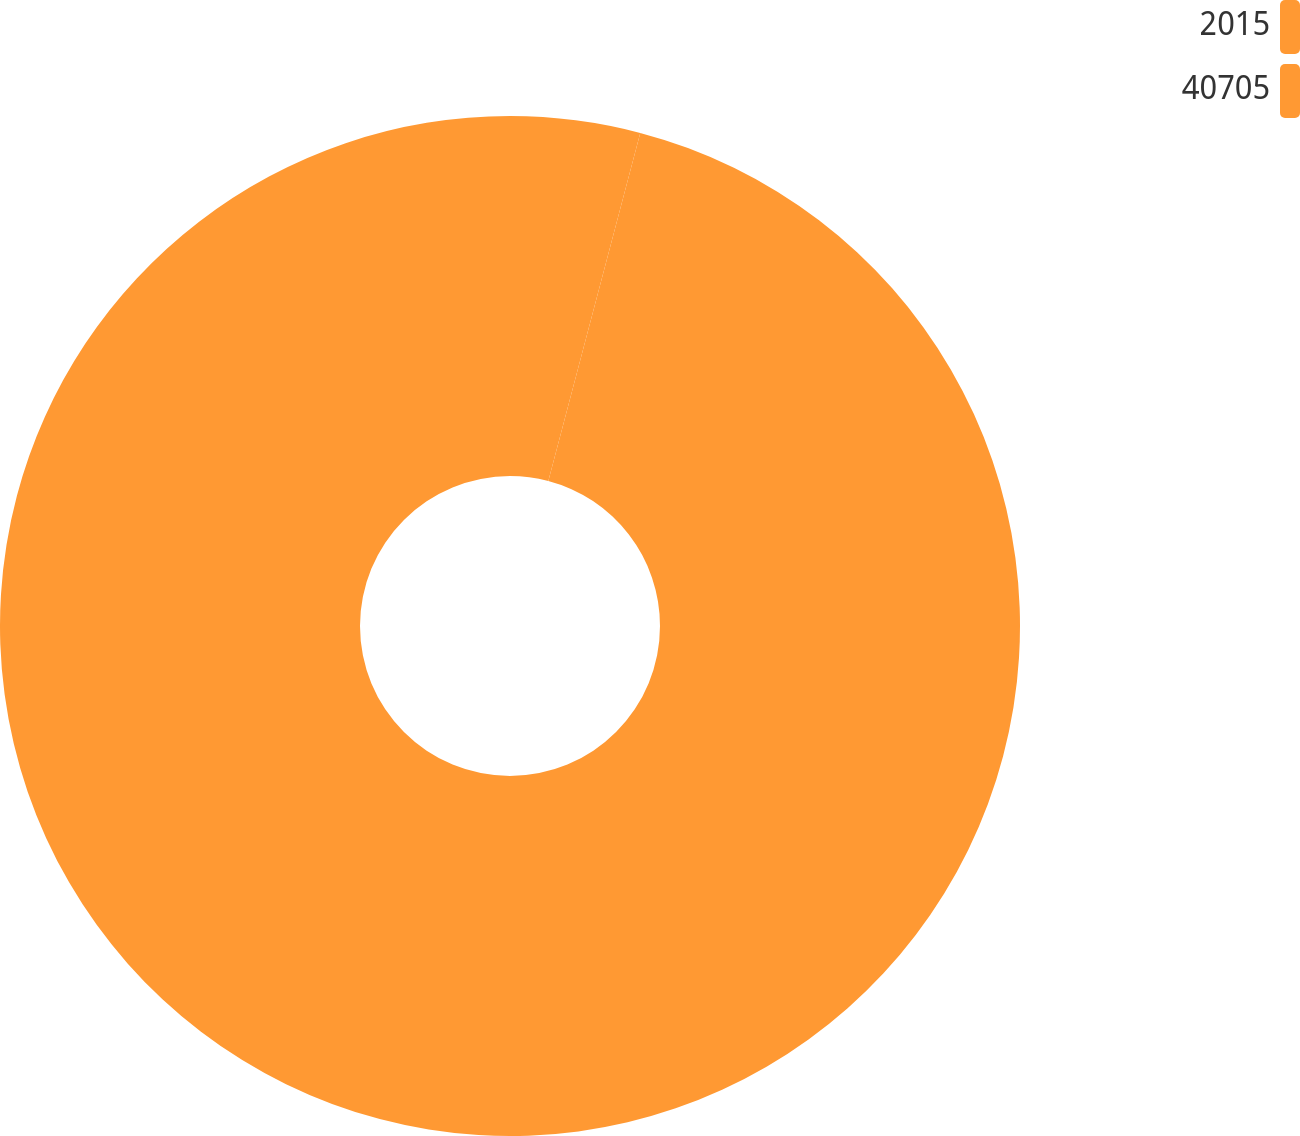<chart> <loc_0><loc_0><loc_500><loc_500><pie_chart><fcel>2015<fcel>40705<nl><fcel>4.11%<fcel>95.89%<nl></chart> 